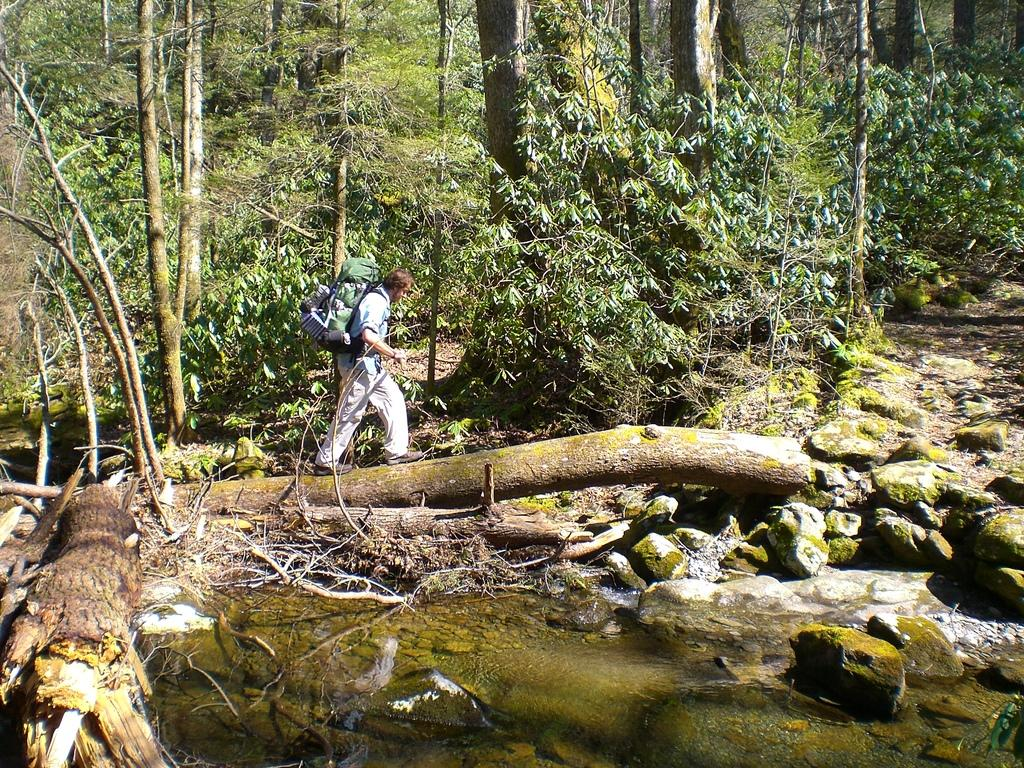What type of natural environment is depicted in the image? There are many trees and water visible in the image, suggesting a forest or woodland setting. What other elements can be seen in the image besides trees and water? There are rocks in the image. What is the person in the image doing? The person is walking on a wooden log in the image. What might the person be carrying? The person is carrying objects in the image. What color is the pencil being used by the person in the image? There is no pencil present in the image; the person is walking on a wooden log and carrying objects. 